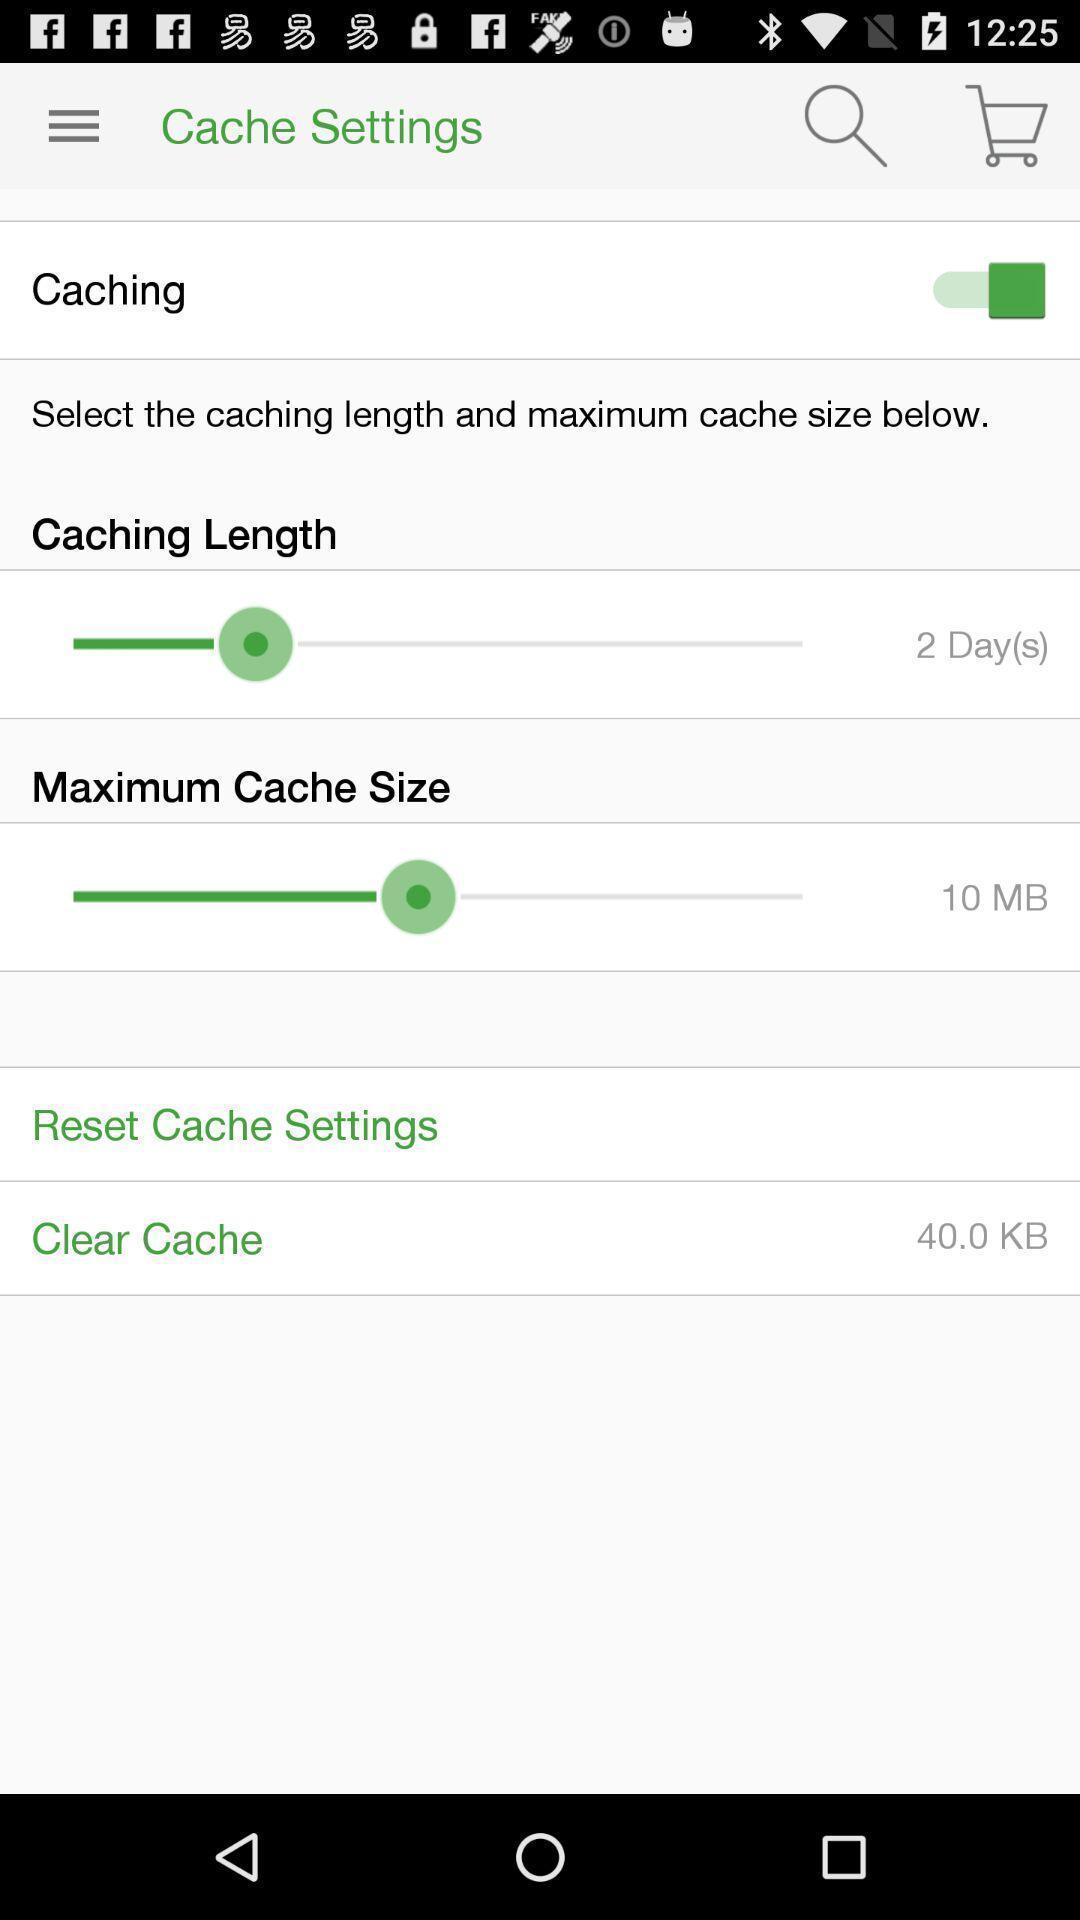Provide a detailed account of this screenshot. Page showing cache settings on app. 